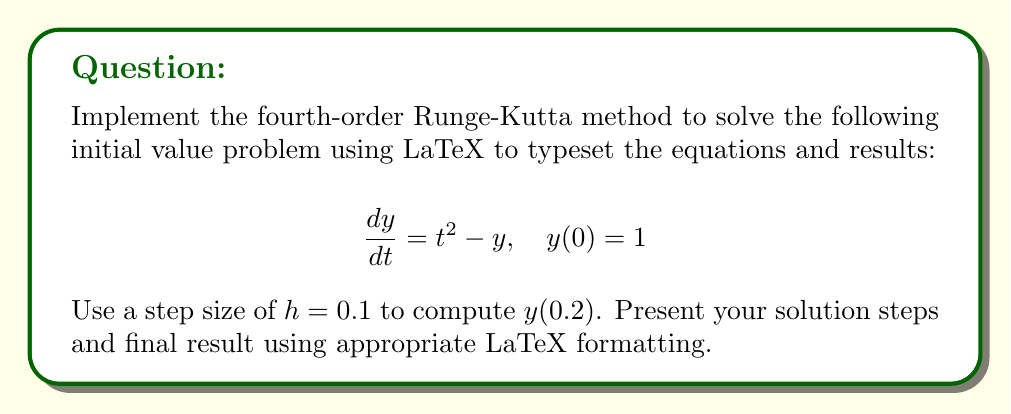What is the answer to this math problem? The fourth-order Runge-Kutta method for solving ODEs is given by:

$$y_{n+1} = y_n + \frac{1}{6}(k_1 + 2k_2 + 2k_3 + k_4)$$

where:

$$\begin{aligned}
k_1 &= hf(t_n, y_n) \\
k_2 &= hf(t_n + \frac{h}{2}, y_n + \frac{k_1}{2}) \\
k_3 &= hf(t_n + \frac{h}{2}, y_n + \frac{k_2}{2}) \\
k_4 &= hf(t_n + h, y_n + k_3)
\end{aligned}$$

For our problem, $f(t, y) = t^2 - y$.

Step 1: Calculate $y(0.1)$
$t_0 = 0$, $y_0 = 1$, $h = 0.1$

$$\begin{aligned}
k_1 &= 0.1(0^2 - 1) = -0.1 \\
k_2 &= 0.1((0.05)^2 - (1 - 0.05)) = -0.09975 \\
k_3 &= 0.1((0.05)^2 - (1 - 0.049875)) = -0.09975625 \\
k_4 &= 0.1((0.1)^2 - (1 - 0.09975625)) = -0.0990025
\end{aligned}$$

$$y_1 = 1 + \frac{1}{6}(-0.1 - 2(0.09975) - 2(0.09975625) - 0.0990025) = 0.90024792$$

Step 2: Calculate $y(0.2)$
$t_1 = 0.1$, $y_1 = 0.90024792$, $h = 0.1$

$$\begin{aligned}
k_1 &= 0.1((0.1)^2 - 0.90024792) = -0.08924792 \\
k_2 &= 0.1((0.15)^2 - (0.90024792 - 0.04462396)) = -0.08478956 \\
k_3 &= 0.1((0.15)^2 - (0.90024792 - 0.04239478)) = -0.08479956 \\
k_4 &= 0.1((0.2)^2 - (0.90024792 - 0.08479956)) = -0.07944836
\end{aligned}$$

$$y_2 = 0.90024792 + \frac{1}{6}(-0.08924792 - 2(0.08478956) - 2(0.08479956) - 0.07944836) = 0.81457877$$
Answer: $y(0.2) \approx 0.81457877$ 